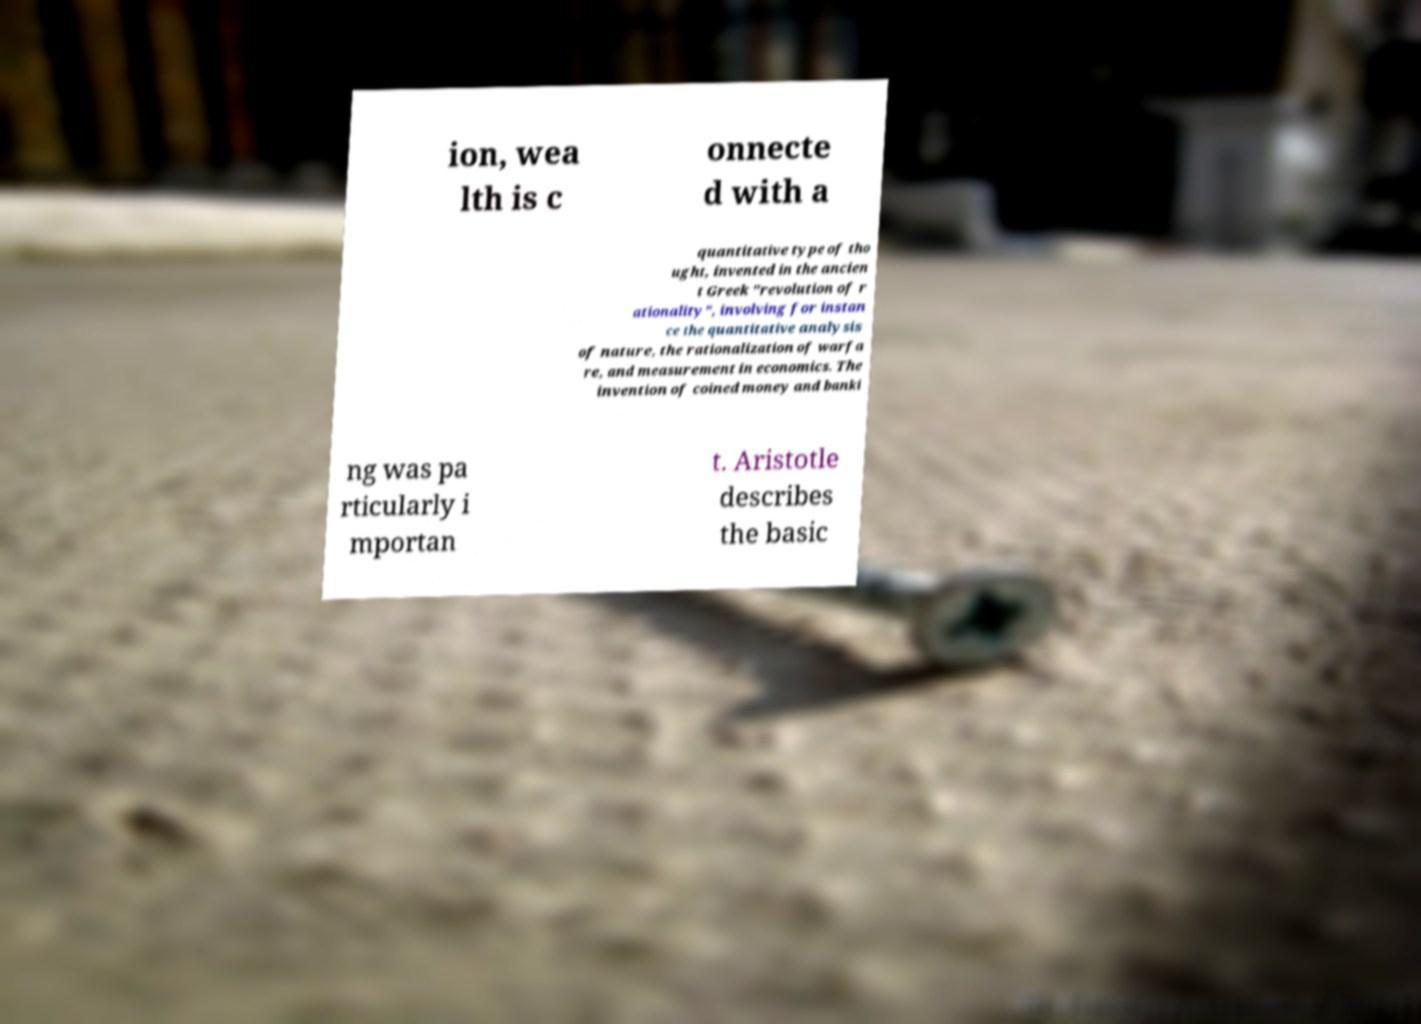Can you accurately transcribe the text from the provided image for me? ion, wea lth is c onnecte d with a quantitative type of tho ught, invented in the ancien t Greek "revolution of r ationality", involving for instan ce the quantitative analysis of nature, the rationalization of warfa re, and measurement in economics. The invention of coined money and banki ng was pa rticularly i mportan t. Aristotle describes the basic 